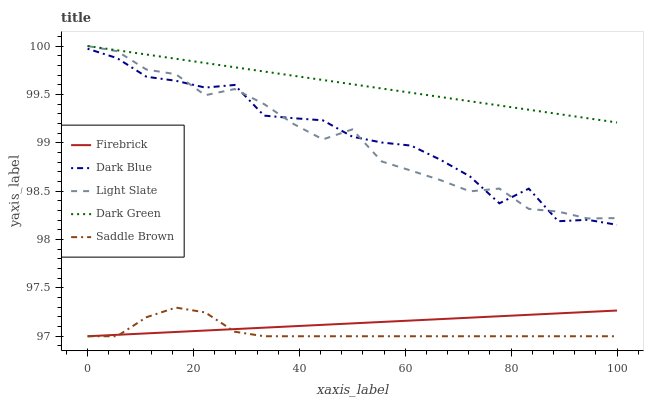Does Saddle Brown have the minimum area under the curve?
Answer yes or no. Yes. Does Dark Green have the maximum area under the curve?
Answer yes or no. Yes. Does Dark Blue have the minimum area under the curve?
Answer yes or no. No. Does Dark Blue have the maximum area under the curve?
Answer yes or no. No. Is Firebrick the smoothest?
Answer yes or no. Yes. Is Dark Blue the roughest?
Answer yes or no. Yes. Is Dark Blue the smoothest?
Answer yes or no. No. Is Firebrick the roughest?
Answer yes or no. No. Does Firebrick have the lowest value?
Answer yes or no. Yes. Does Dark Blue have the lowest value?
Answer yes or no. No. Does Dark Green have the highest value?
Answer yes or no. Yes. Does Dark Blue have the highest value?
Answer yes or no. No. Is Firebrick less than Light Slate?
Answer yes or no. Yes. Is Dark Green greater than Dark Blue?
Answer yes or no. Yes. Does Firebrick intersect Saddle Brown?
Answer yes or no. Yes. Is Firebrick less than Saddle Brown?
Answer yes or no. No. Is Firebrick greater than Saddle Brown?
Answer yes or no. No. Does Firebrick intersect Light Slate?
Answer yes or no. No. 